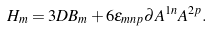<formula> <loc_0><loc_0><loc_500><loc_500>H _ { m } = 3 D B _ { m } + 6 \epsilon _ { m n p } \partial A ^ { 1 n } A ^ { 2 p } .</formula> 